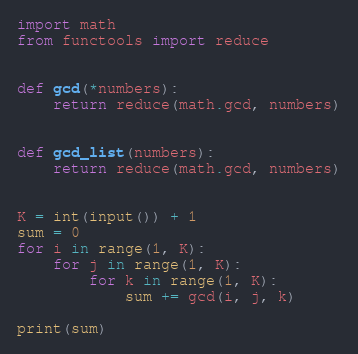<code> <loc_0><loc_0><loc_500><loc_500><_Python_>import math
from functools import reduce


def gcd(*numbers):
    return reduce(math.gcd, numbers)


def gcd_list(numbers):
    return reduce(math.gcd, numbers)


K = int(input()) + 1
sum = 0
for i in range(1, K):
    for j in range(1, K):
        for k in range(1, K):
            sum += gcd(i, j, k)

print(sum)
</code> 